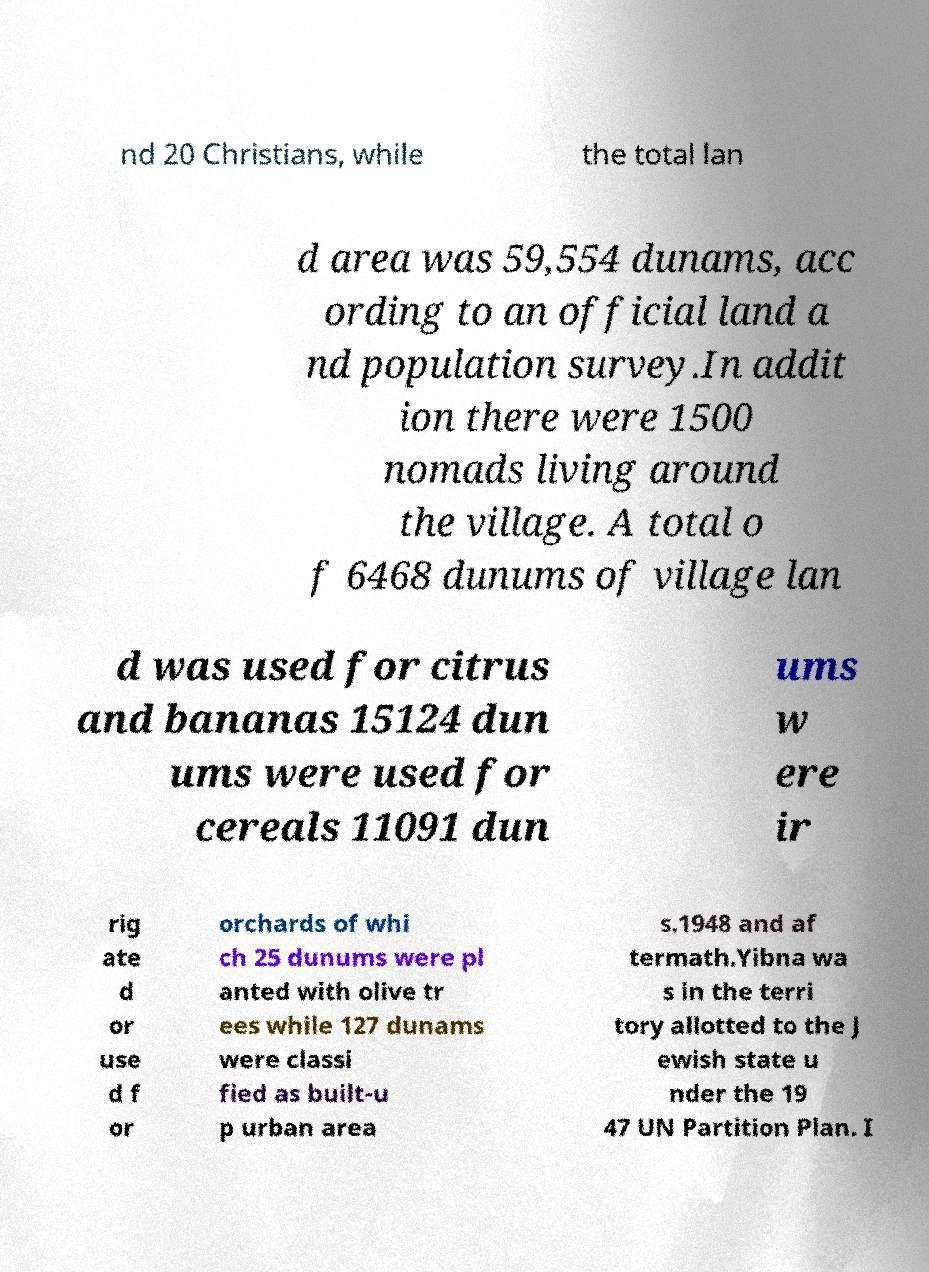Can you accurately transcribe the text from the provided image for me? nd 20 Christians, while the total lan d area was 59,554 dunams, acc ording to an official land a nd population survey.In addit ion there were 1500 nomads living around the village. A total o f 6468 dunums of village lan d was used for citrus and bananas 15124 dun ums were used for cereals 11091 dun ums w ere ir rig ate d or use d f or orchards of whi ch 25 dunums were pl anted with olive tr ees while 127 dunams were classi fied as built-u p urban area s.1948 and af termath.Yibna wa s in the terri tory allotted to the J ewish state u nder the 19 47 UN Partition Plan. I 